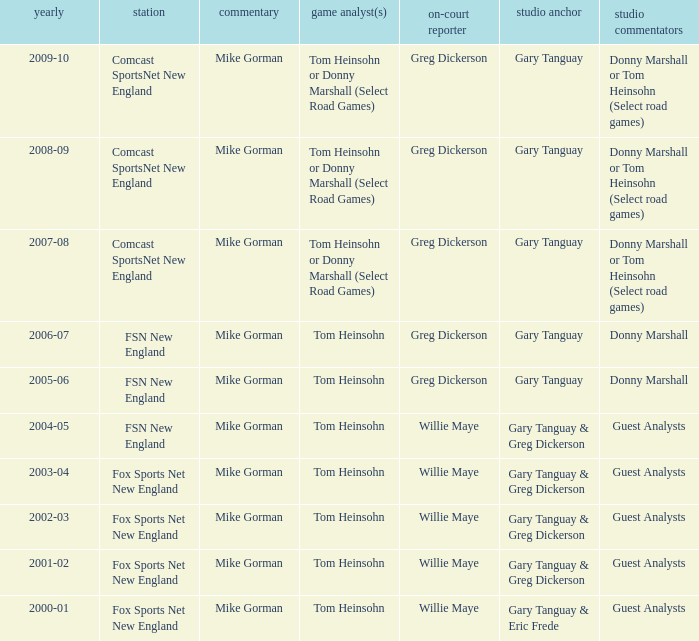Which Color commentator has a Channel of fsn new england, and a Year of 2004-05? Tom Heinsohn. 